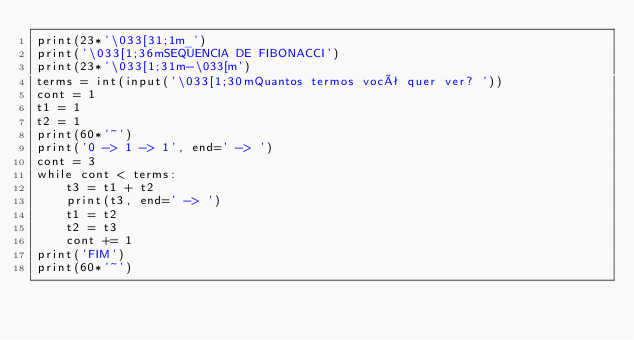Convert code to text. <code><loc_0><loc_0><loc_500><loc_500><_Python_>print(23*'\033[31;1m_')
print('\033[1;36mSEQUENCIA DE FIBONACCI')
print(23*'\033[1;31m-\033[m')
terms = int(input('\033[1;30mQuantos termos você quer ver? '))
cont = 1
t1 = 1
t2 = 1
print(60*'~')
print('0 -> 1 -> 1', end=' -> ')
cont = 3
while cont < terms:
    t3 = t1 + t2
    print(t3, end=' -> ')
    t1 = t2
    t2 = t3
    cont += 1
print('FIM')
print(60*'~')
</code> 